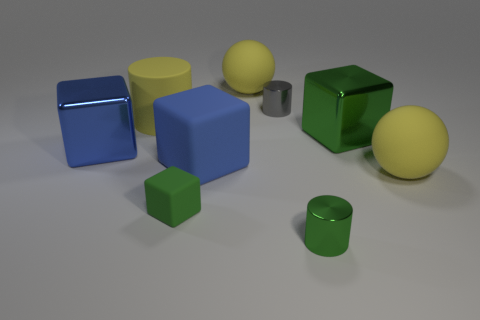Is there a small object that has the same color as the rubber cylinder?
Provide a short and direct response. No. How many other objects are there of the same material as the large yellow cylinder?
Ensure brevity in your answer.  4. There is a tiny metallic object that is the same color as the tiny matte cube; what shape is it?
Your response must be concise. Cylinder. There is a tiny metal thing in front of the tiny cube; is its shape the same as the big green metallic thing?
Your answer should be very brief. No. What material is the other blue object that is the same shape as the blue shiny object?
Provide a succinct answer. Rubber. Is the shape of the green matte thing the same as the large yellow matte object to the left of the green rubber object?
Make the answer very short. No. What color is the cylinder that is both to the right of the large rubber block and behind the large blue shiny thing?
Ensure brevity in your answer.  Gray. Are any tiny brown shiny things visible?
Provide a succinct answer. No. Is the number of big matte spheres right of the small green shiny cylinder the same as the number of large yellow balls?
Give a very brief answer. No. What number of other things are the same shape as the gray thing?
Offer a very short reply. 2. 